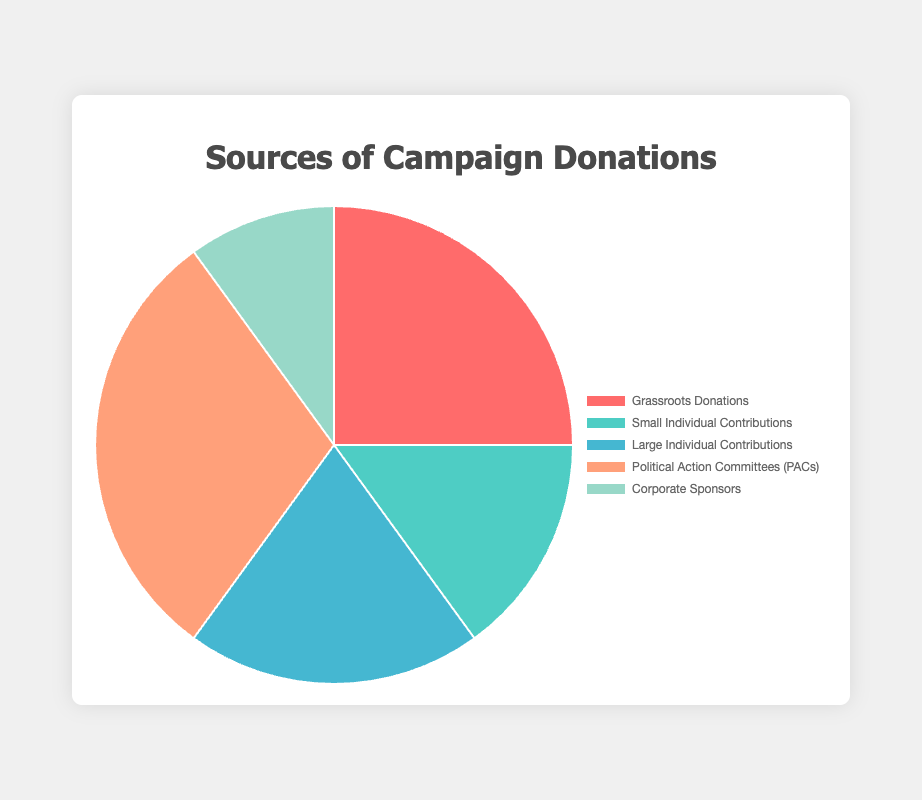What percentage of the total donations come from Political Action Committees (PACs)? First, sum up all the donations: 2500000 (Grassroots) + 1500000 (Small Individual) + 2000000 (Large Individual) + 3000000 (PACs) + 1000000 (Corporate) = 10000000. PACs contribute 3000000. The percentage is 3000000 / 10000000 * 100 = 30%.
Answer: 30% Which donation type contributes the least to the total donations? Compare the amounts: Grassroots (2500000), Small Individual (1500000), Large Individual (2000000), PACs (3000000), Corporate (1000000). The lowest is Corporate Sponsors with 1000000.
Answer: Corporate Sponsors What is the difference in the amount of donations between Grassroots Donations and Large Individual Contributions? Subtract the smaller from the larger: 2500000 (Grassroots) - 2000000 (Large Individual) = 500000.
Answer: 500000 What is the total amount of donations received from individual contributions (sum of Small and Large Individual Contributions)? Add the donations from Small and Large Individual Contributions: 1500000 + 2000000 = 3500000.
Answer: 3500000 What color represents the Grassroots Donations in the chart? The color for Grassroots Donations can be identified by looking at the legend. Grassroots Donations are represented by the red segment.
Answer: Red How does the amount of Small Individual Contributions compare to Corporate Sponsors? Compare the amounts: Small Individual Contributions (1500000) and Corporate Sponsors (1000000). Small Individual Contributions are greater.
Answer: Small Individual Contributions are greater What is the total percentage of donations from Grassroots Donations and PACs combined? First, sum their amounts: 2500000 (Grassroots) + 3000000 (PACs) = 5500000. Calculate the percentage: 5500000 / 10000000 * 100 = 55%.
Answer: 55% How much more do PACs contribute compared to Small Individual Contributions? Subtract the smaller value from the larger: 3000000 (PACs) - 1500000 (Small Individual) = 1500000.
Answer: 1500000 Which two donation types combined make up exactly half of the total donations? Calculate combinations to find which add up to 5000000: PACs (3000000) + Grassroots (2500000) = 5500000; PACs (3000000) + Large Individual (2000000) = 5000000.
Answer: PACs and Large Individual Contributions What percentage of the total donations come from Corporate Sponsors and Small Individual Contributions combined? First, sum their amounts: 1500000 (Small Individual) + 1000000 (Corporate) = 2500000. Calculate the percentage: 2500000 / 10000000 * 100 = 25%.
Answer: 25% 